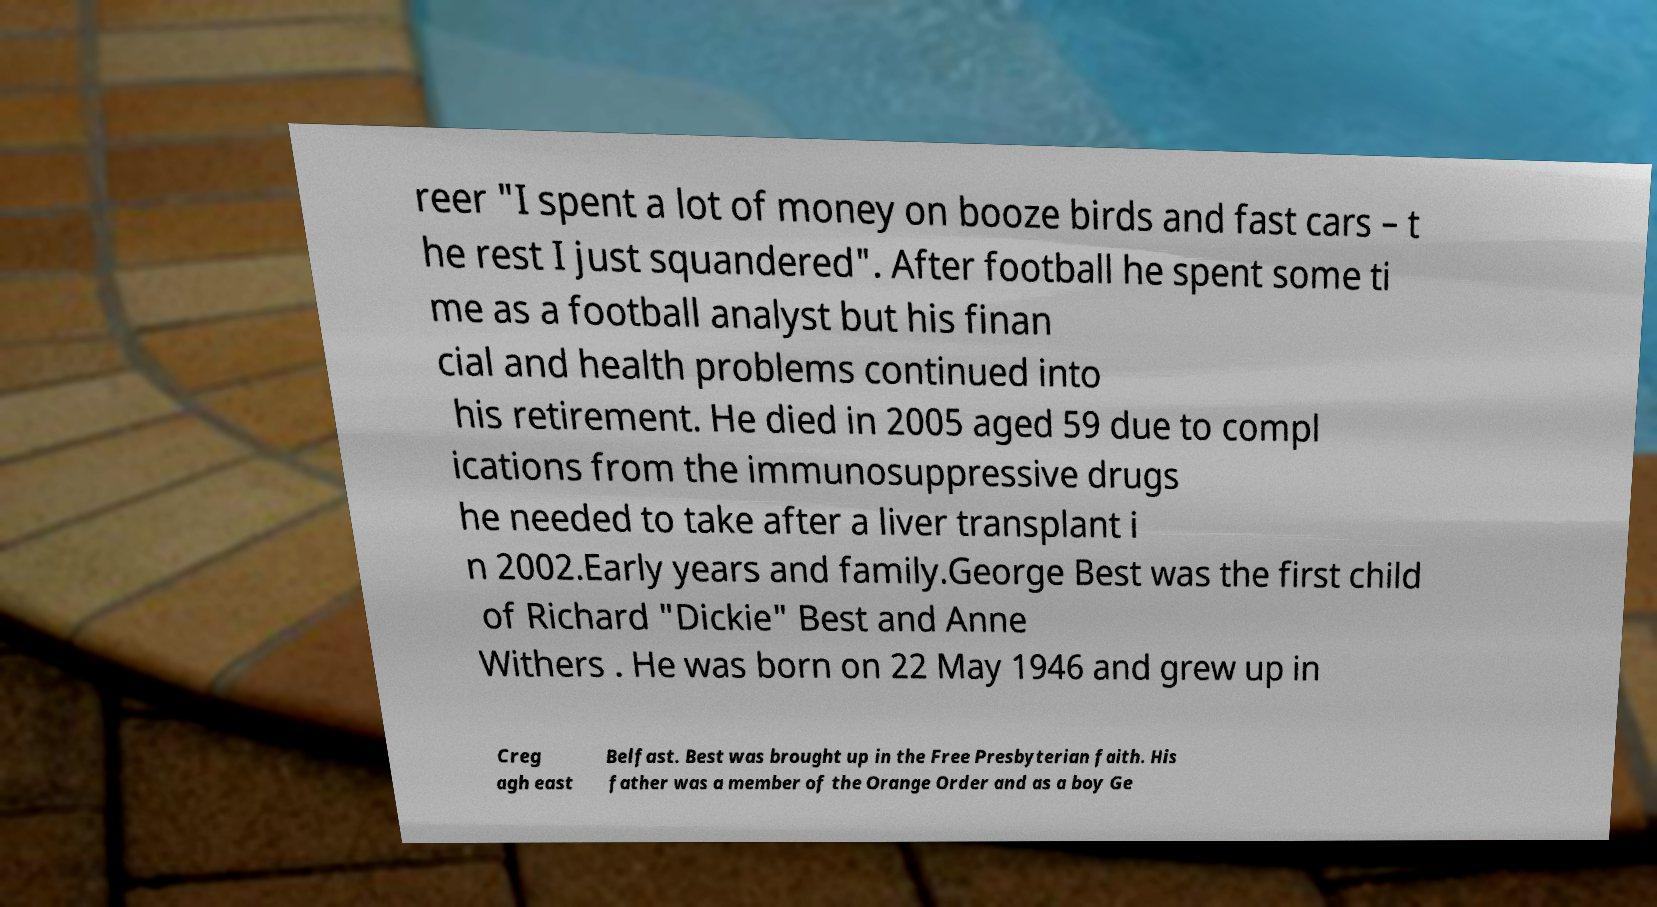Can you accurately transcribe the text from the provided image for me? reer "I spent a lot of money on booze birds and fast cars – t he rest I just squandered". After football he spent some ti me as a football analyst but his finan cial and health problems continued into his retirement. He died in 2005 aged 59 due to compl ications from the immunosuppressive drugs he needed to take after a liver transplant i n 2002.Early years and family.George Best was the first child of Richard "Dickie" Best and Anne Withers . He was born on 22 May 1946 and grew up in Creg agh east Belfast. Best was brought up in the Free Presbyterian faith. His father was a member of the Orange Order and as a boy Ge 